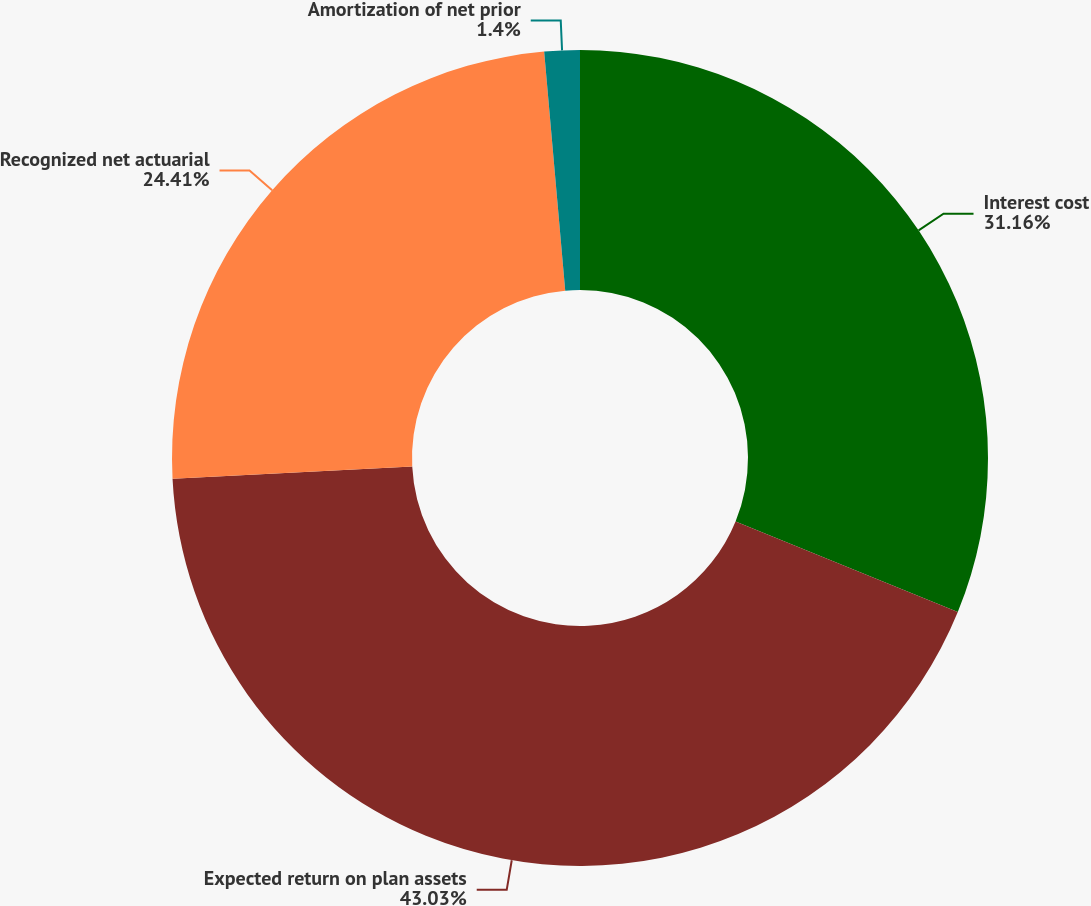Convert chart to OTSL. <chart><loc_0><loc_0><loc_500><loc_500><pie_chart><fcel>Interest cost<fcel>Expected return on plan assets<fcel>Recognized net actuarial<fcel>Amortization of net prior<nl><fcel>31.16%<fcel>43.02%<fcel>24.41%<fcel>1.4%<nl></chart> 